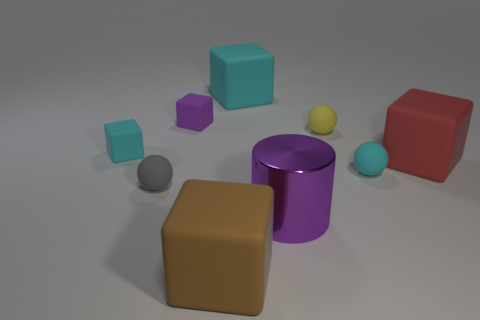What is the shape of the small object that is the same color as the big metal object?
Ensure brevity in your answer.  Cube. What size is the matte thing that is the same color as the cylinder?
Make the answer very short. Small. Are there any tiny gray rubber objects that are to the right of the large cube in front of the large block that is on the right side of the purple metal cylinder?
Your answer should be compact. No. What number of things have the same size as the cyan matte ball?
Offer a very short reply. 4. There is a cyan block behind the yellow sphere; is it the same size as the purple thing in front of the yellow matte thing?
Keep it short and to the point. Yes. There is a large thing that is both on the left side of the large purple cylinder and behind the purple cylinder; what shape is it?
Make the answer very short. Cube. Are there any matte objects of the same color as the large cylinder?
Offer a terse response. Yes. Are any red cubes visible?
Provide a succinct answer. Yes. What color is the big object to the right of the purple metallic cylinder?
Your answer should be compact. Red. Does the purple matte thing have the same size as the cyan matte object right of the purple metallic cylinder?
Make the answer very short. Yes. 